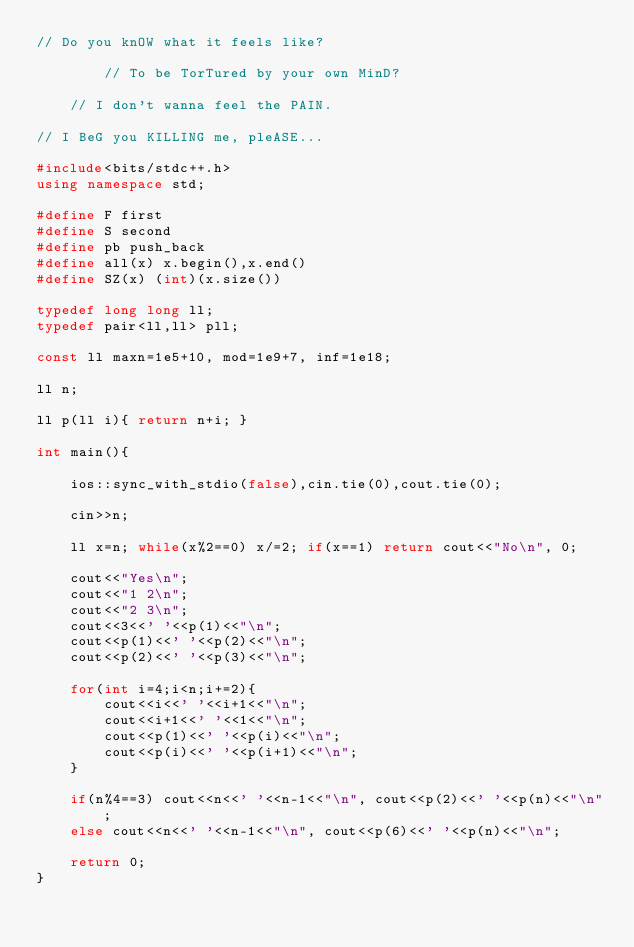<code> <loc_0><loc_0><loc_500><loc_500><_C++_>// Do you knOW what it feels like?

		// To be TorTured by your own MinD?
	
	// I don't wanna feel the PAIN.

// I BeG you KILLING me, pleASE...

#include<bits/stdc++.h>
using namespace std;

#define F first
#define S second
#define pb push_back
#define all(x) x.begin(),x.end()
#define SZ(x) (int)(x.size())

typedef long long ll;
typedef pair<ll,ll> pll;

const ll maxn=1e5+10, mod=1e9+7, inf=1e18;

ll n;

ll p(ll i){ return n+i; }

int main(){
	
	ios::sync_with_stdio(false),cin.tie(0),cout.tie(0);
	
	cin>>n;

	ll x=n; while(x%2==0) x/=2; if(x==1) return cout<<"No\n", 0;

	cout<<"Yes\n";
	cout<<"1 2\n";
	cout<<"2 3\n";
	cout<<3<<' '<<p(1)<<"\n";
	cout<<p(1)<<' '<<p(2)<<"\n";
	cout<<p(2)<<' '<<p(3)<<"\n";
		
	for(int i=4;i<n;i+=2){
		cout<<i<<' '<<i+1<<"\n";
		cout<<i+1<<' '<<1<<"\n";
		cout<<p(1)<<' '<<p(i)<<"\n";
		cout<<p(i)<<' '<<p(i+1)<<"\n";
	}

	if(n%4==3) cout<<n<<' '<<n-1<<"\n", cout<<p(2)<<' '<<p(n)<<"\n";
	else cout<<n<<' '<<n-1<<"\n", cout<<p(6)<<' '<<p(n)<<"\n";

	return 0;
}




















</code> 